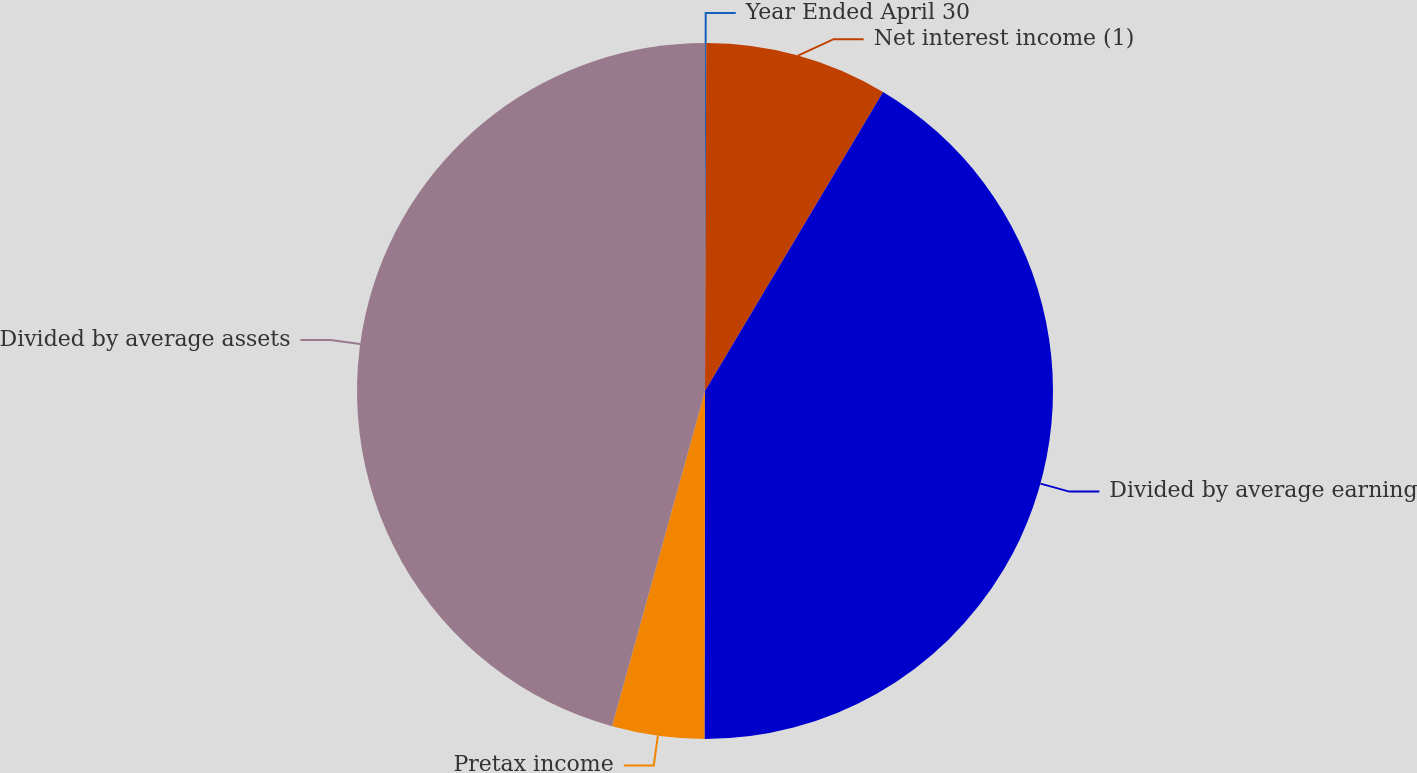<chart> <loc_0><loc_0><loc_500><loc_500><pie_chart><fcel>Year Ended April 30<fcel>Net interest income (1)<fcel>Divided by average earning<fcel>Pretax income<fcel>Divided by average assets<nl><fcel>0.06%<fcel>8.49%<fcel>41.48%<fcel>4.28%<fcel>45.7%<nl></chart> 